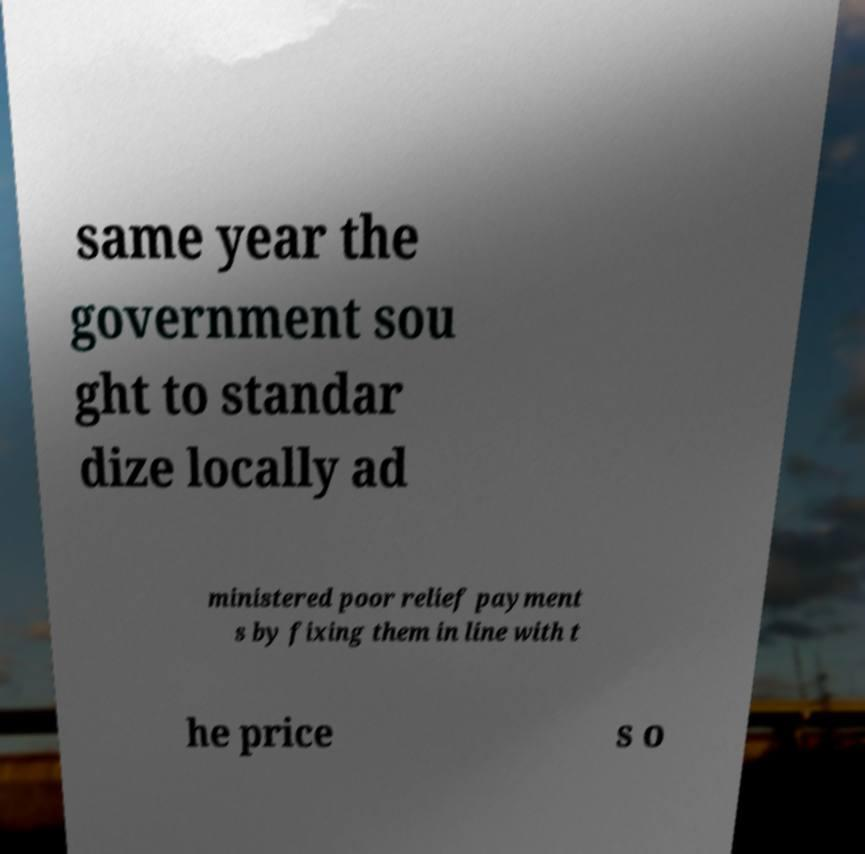Please read and relay the text visible in this image. What does it say? same year the government sou ght to standar dize locally ad ministered poor relief payment s by fixing them in line with t he price s o 